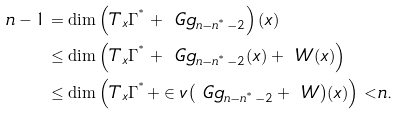<formula> <loc_0><loc_0><loc_500><loc_500>{ n } - 1 & = \dim { \left ( T _ { x } \Gamma ^ { ^ { * } } + \ G g _ { n - n ^ { ^ { * } } - 2 } \right ) ( x ) } \\ & \leq \dim { \left ( T _ { x } \Gamma ^ { ^ { * } } + \ G g _ { n - n ^ { ^ { * } } - 2 } ( x ) + \ W ( x ) \right ) } \\ & \leq \dim { \left ( T _ { x } \Gamma ^ { ^ { * } } + \in v { \left ( \ G g _ { n - n ^ { ^ { * } } - 2 } + \ W \right ) } ( x ) \right ) } < n .</formula> 